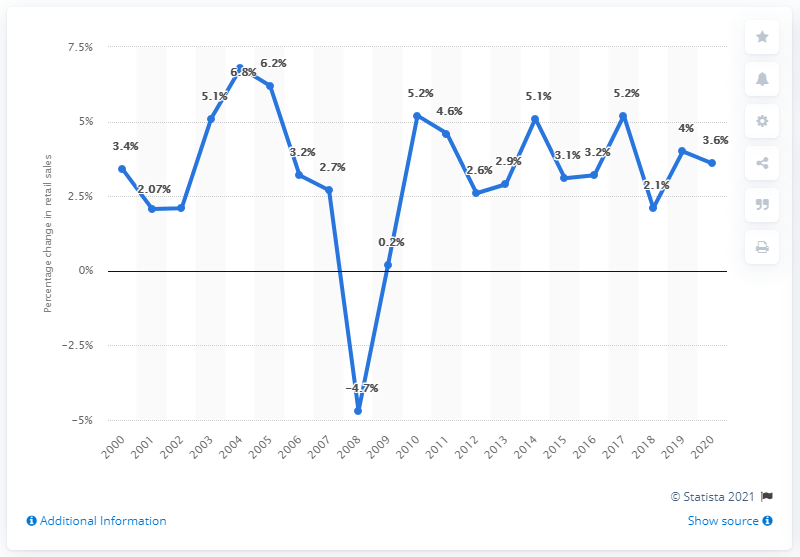Draw attention to some important aspects in this diagram. In 2020, retail sales during the holiday season were projected to increase by 3.6%. 